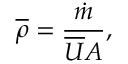<formula> <loc_0><loc_0><loc_500><loc_500>{ \overline { \rho } } = { \frac { \dot { m } } { { \overline { U } } A } } ,</formula> 